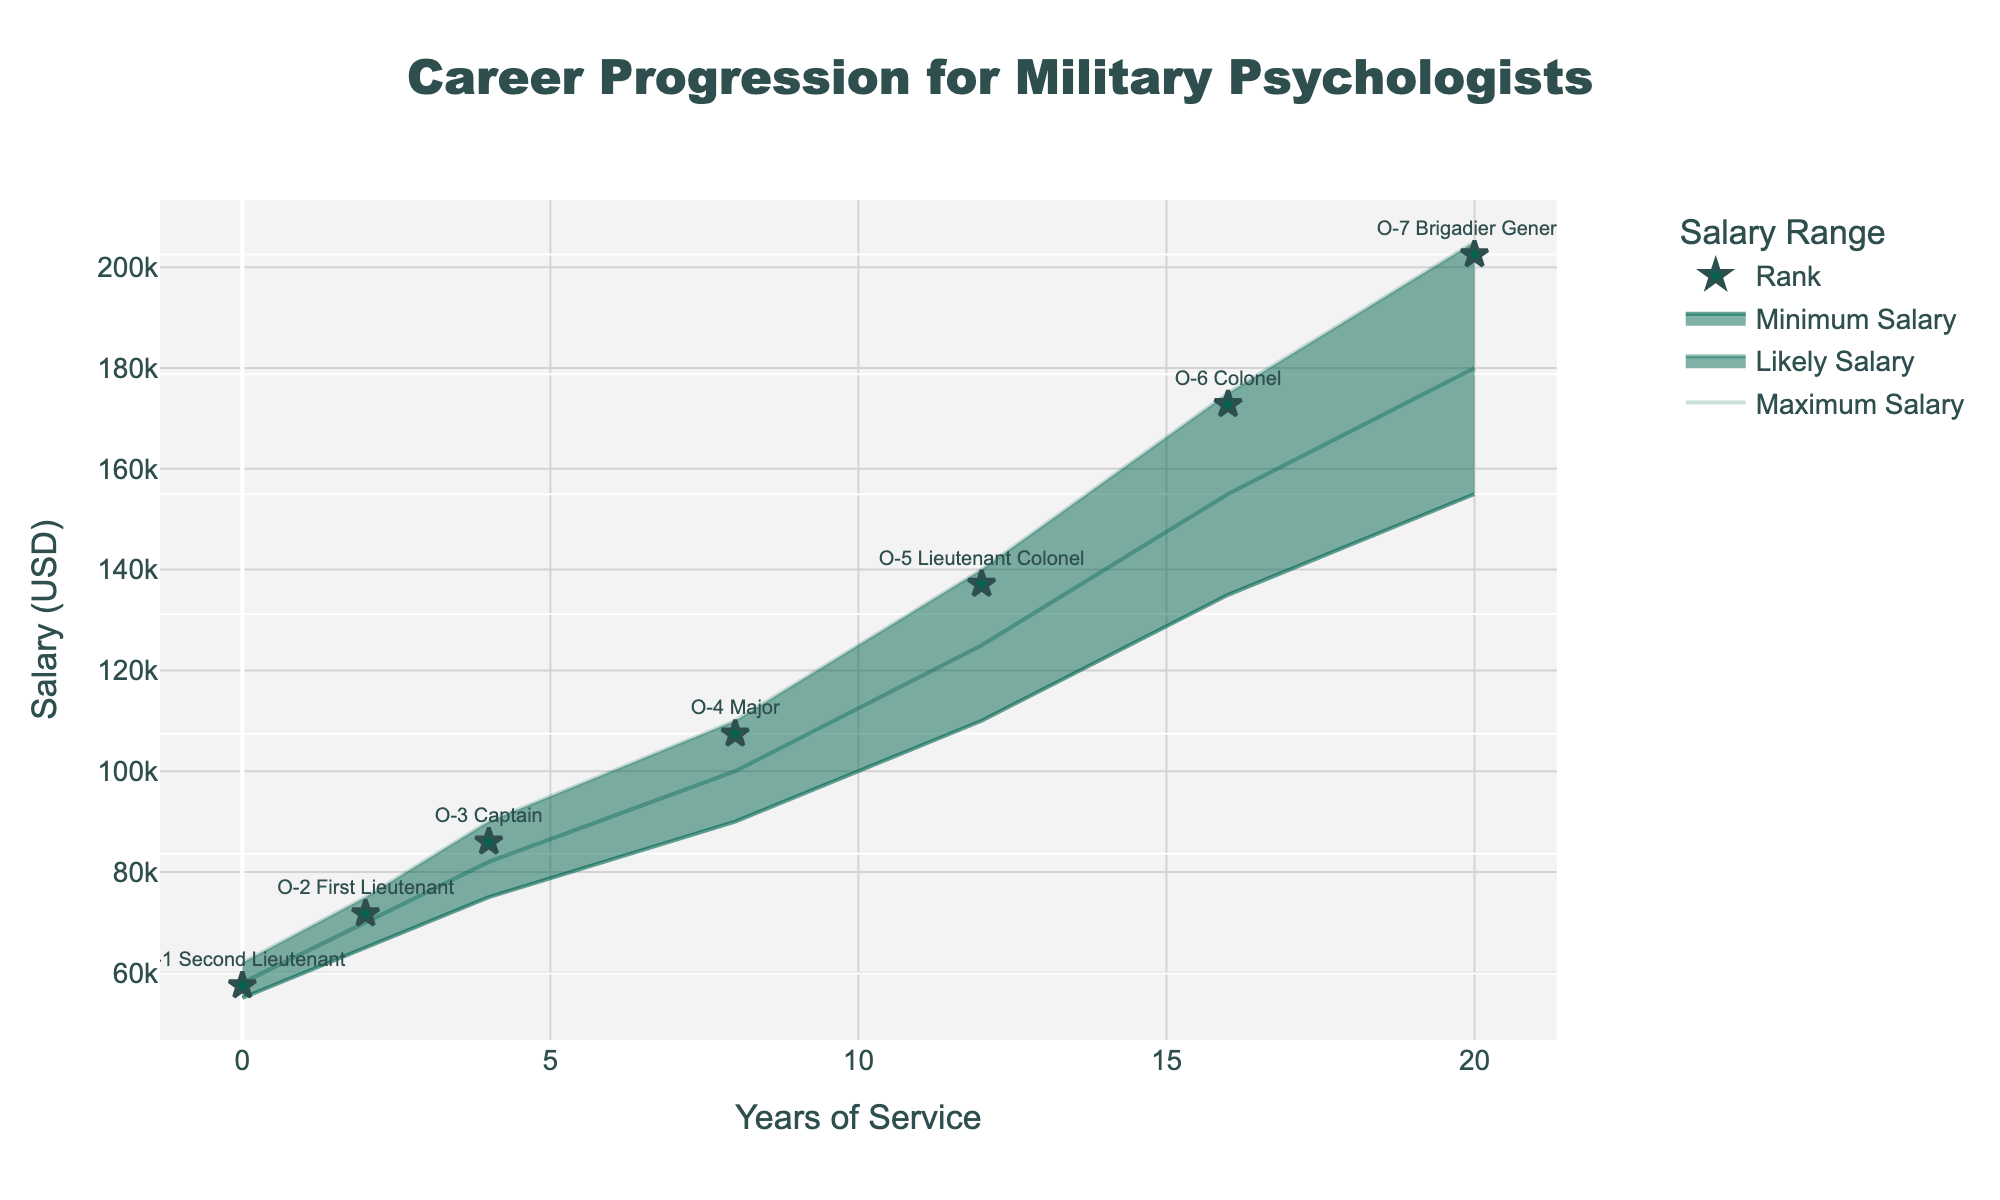What's the maximum salary for an O-5 Lieutenant Colonel? The maximum salary can be found directly in the chart's shaded area for the O-5 Lieutenant Colonel rank around the 12-year mark.
Answer: 140,000 What's the title of the figure? The title is displayed at the top center of the figure.
Answer: Career Progression for Military Psychologists How many ranks are shown in the figure? The ranks are listed and associated with each year in the visual markers on the chart. Count the number of unique ranks.
Answer: 7 What's the salary range for an O-2 First Lieutenant? Look at the corresponding position for O-2 First Lieutenant, around the second year, and read the minimum and maximum salary values.
Answer: 65,000 to 75,000 How does the likely salary for an O-4 Major at 8 years compare to the minimum salary for an O-3 Captain at 4 years? Find the likely salary for an O-4 Major at 8 years and compare it with the minimum salary for an O-3 Captain at 4 years by observing and comparing their positions in the shaded areas.
Answer: 100,000 vs. 75,000 What's the average of the minimum and maximum salary for an O-6 Colonel? Identify the minimum and maximum salary for O-6 Colonel, add them together, then divide the sum by 2. (135,000 + 175,000) / 2 = 155,000
Answer: 155,000 How much does the maximum salary increase from O-1 Second Lieutenant to O-7 Brigadier General? Find the maximum salary for O-1 Second Lieutenant and O-7 Brigadier General, and calculate the difference between them. 205,000 - 62,000
Answer: 143,000 What is the range of likely salaries for each rank, and which rank has the largest range? Observe the likely salary values for each rank and calculate the range by subtracting the minimum likely salary from the maximum likely salary. Then, identify the rank with the largest range.
Answer: O-7 Brigadier General has the largest range with 25,000 (180,000 - 155,000) What rank is associated with a likely salary of around 125,000 dollars? Look at the likely salary line and identify the rank associated with the year that corresponds to around 125,000 dollars.
Answer: O-5 Lieutenant Colonel 